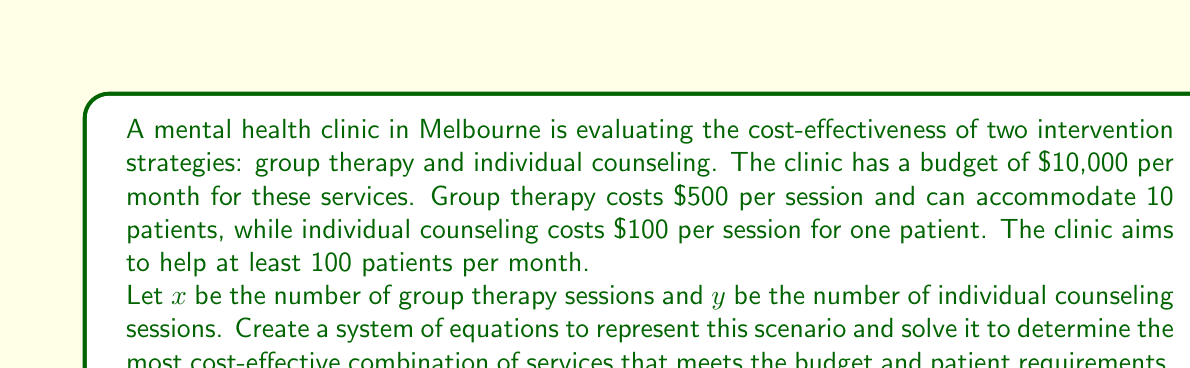Show me your answer to this math problem. Let's approach this step-by-step:

1) First, let's set up our equations based on the given information:

   Budget constraint: $500x + 100y \leq 10000$
   Patient requirement: $10x + y \geq 100$

2) To maximize cost-effectiveness, we want to use the entire budget. So we can change the inequality to an equality for the budget constraint:

   $500x + 100y = 10000$ ... (Equation 1)
   $10x + y \geq 100$ ... (Equation 2)

3) Let's solve Equation 1 for y:

   $100y = 10000 - 500x$
   $y = 100 - 5x$ ... (Equation 3)

4) Substitute this into Equation 2:

   $10x + (100 - 5x) \geq 100$
   $10x + 100 - 5x \geq 100$
   $5x + 100 \geq 100$
   $5x \geq 0$
   $x \geq 0$

5) This tells us that any non-negative value of x will satisfy the patient requirement. To maximize cost-effectiveness, we should use as many group sessions as possible.

6) Substituting x = 20 into Equation 3:

   $y = 100 - 5(20) = 0$

7) Therefore, the most cost-effective solution is 20 group therapy sessions and 0 individual counseling sessions.

8) We can verify:
   Budget: $500(20) + 100(0) = 10000$
   Patients served: $10(20) + 0 = 200$

This solution meets the budget exactly and serves more than the minimum required patients.
Answer: 20 group therapy sessions, 0 individual counseling sessions 